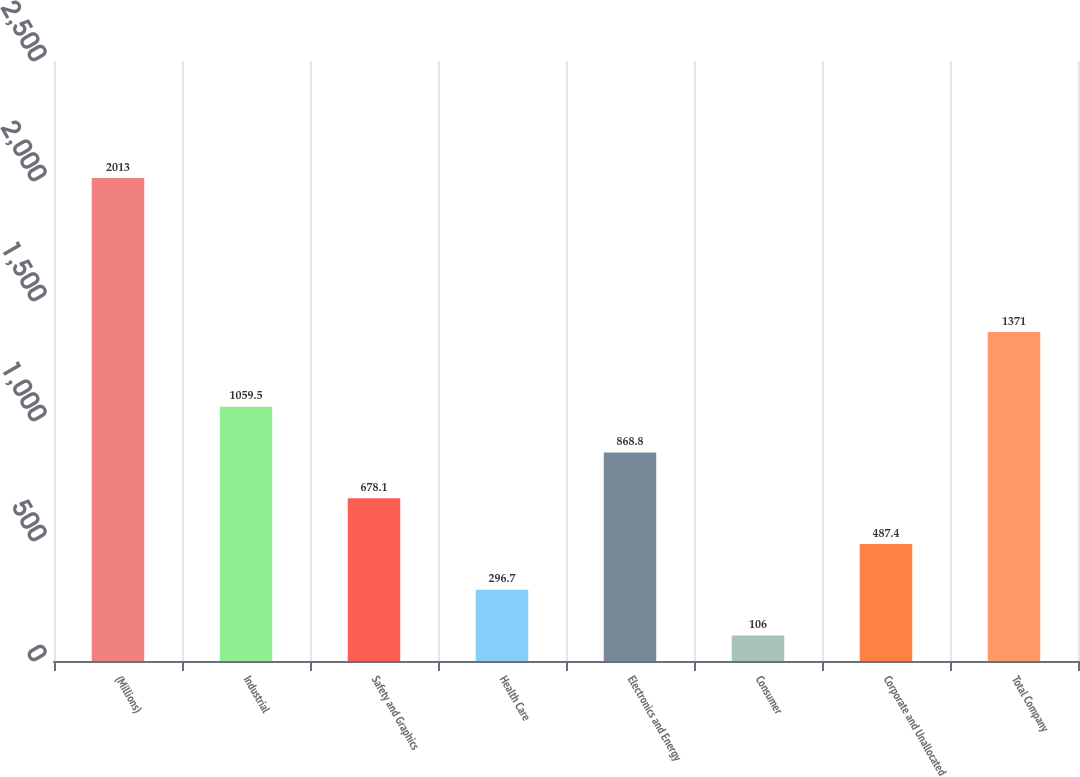Convert chart. <chart><loc_0><loc_0><loc_500><loc_500><bar_chart><fcel>(Millions)<fcel>Industrial<fcel>Safety and Graphics<fcel>Health Care<fcel>Electronics and Energy<fcel>Consumer<fcel>Corporate and Unallocated<fcel>Total Company<nl><fcel>2013<fcel>1059.5<fcel>678.1<fcel>296.7<fcel>868.8<fcel>106<fcel>487.4<fcel>1371<nl></chart> 